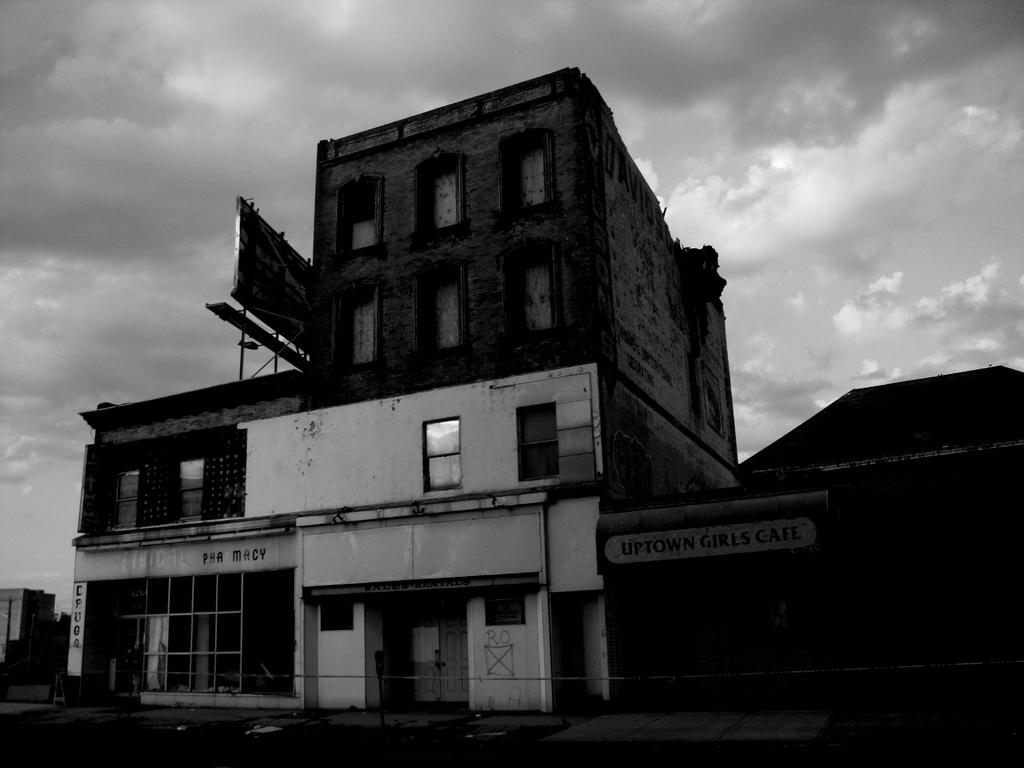What type of structures can be seen in the image? There are buildings in the image. What else is present on the buildings in the image? There are boards with text in the text on the buildings. How would you describe the weather condition in the image? The sky is cloudy in the image. How many guns can be seen in the image? There are no guns present in the image. What type of parcel is being delivered to the building in the image? There is no parcel being delivered in the image; it only shows buildings and boards with text. 